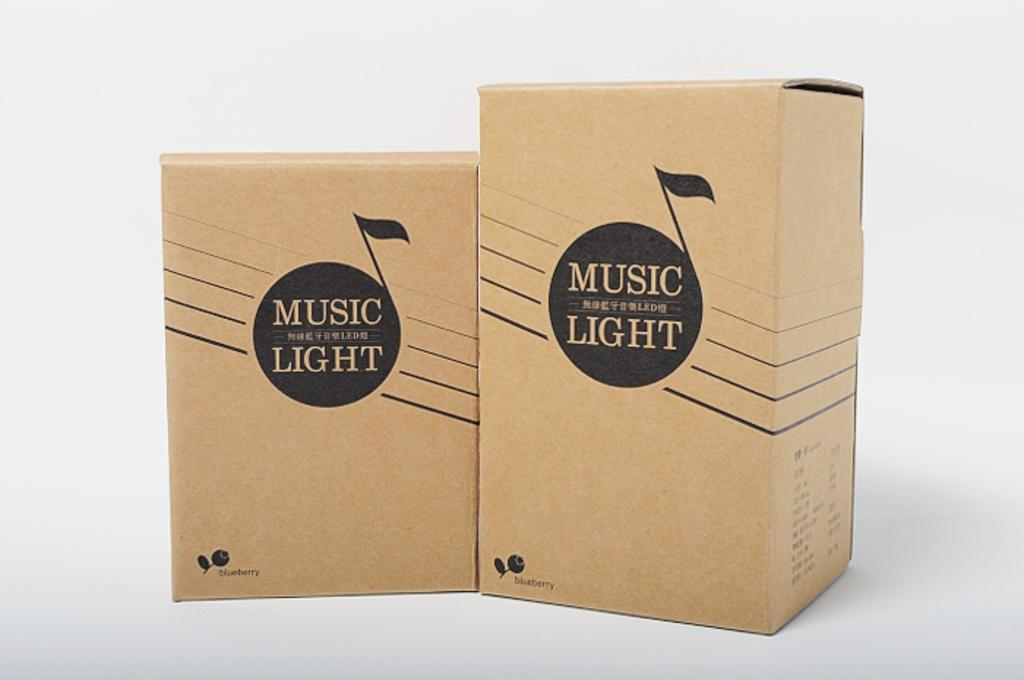<image>
Summarize the visual content of the image. Two boxes that say Music Light sit next to each other in a white room. 